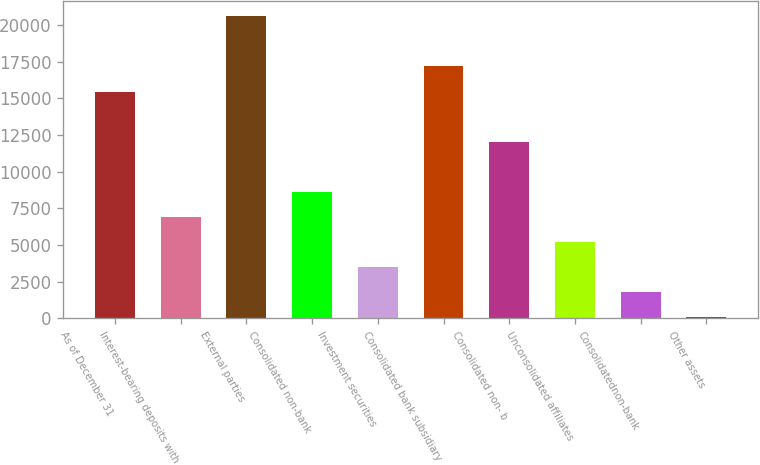<chart> <loc_0><loc_0><loc_500><loc_500><bar_chart><fcel>As of December 31<fcel>Interest-bearing deposits with<fcel>External parties<fcel>Consolidated non-bank<fcel>Investment securities<fcel>Consolidated bank subsidiary<fcel>Consolidated non- b<fcel>Unconsolidated affiliates<fcel>Consolidatednon-bank<fcel>Other assets<nl><fcel>15456.4<fcel>6908.4<fcel>20585.2<fcel>8618<fcel>3489.2<fcel>17166<fcel>12037.2<fcel>5198.8<fcel>1779.6<fcel>70<nl></chart> 